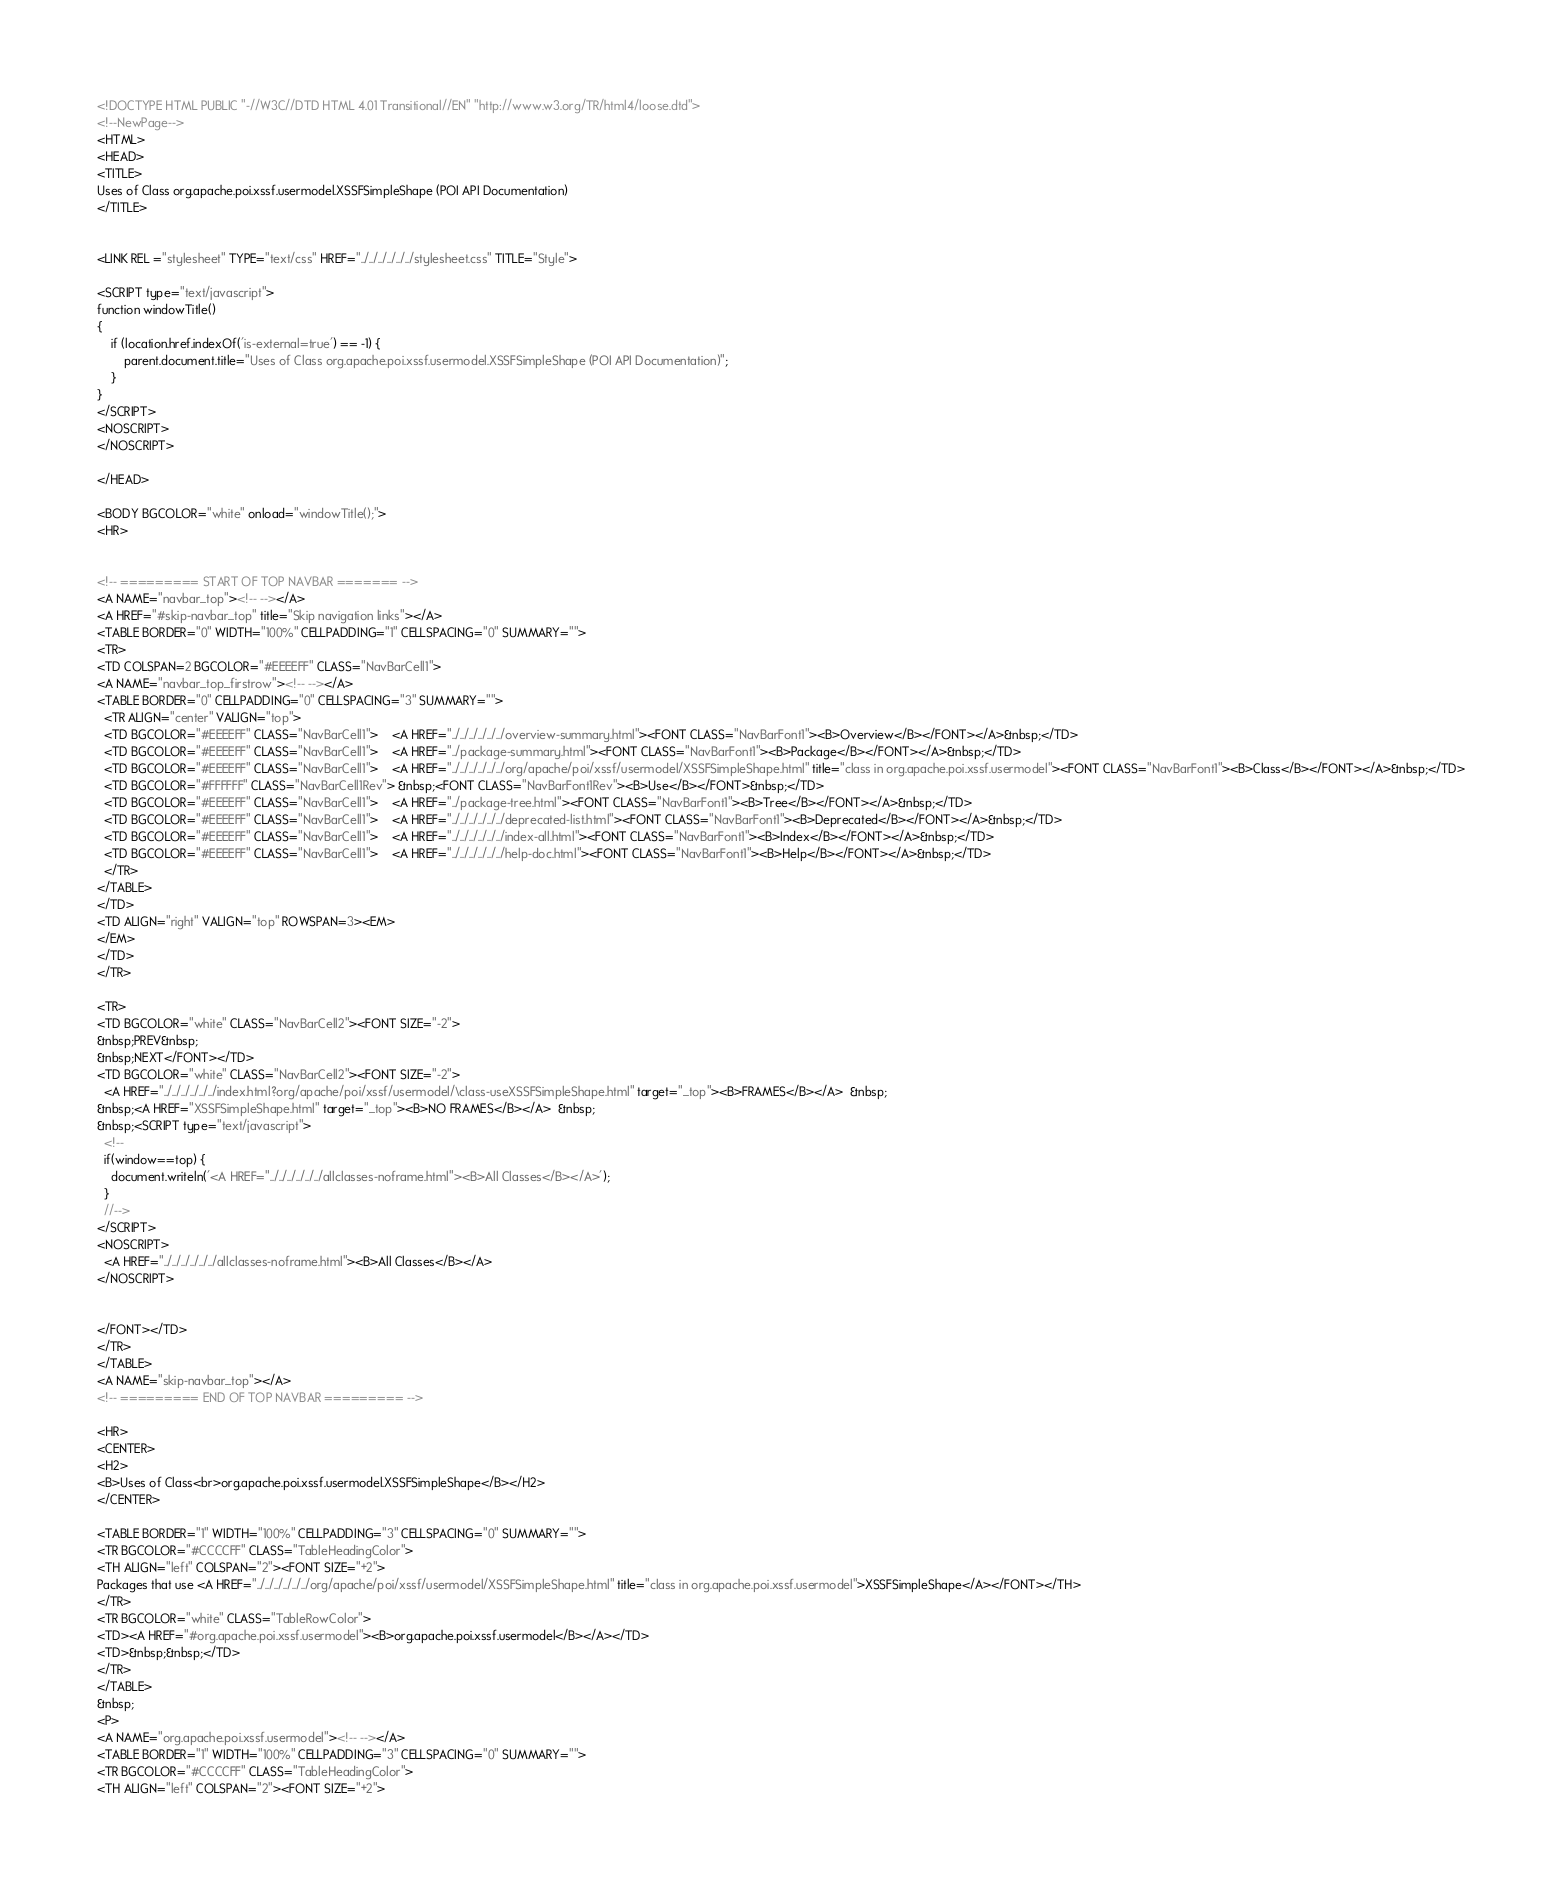Convert code to text. <code><loc_0><loc_0><loc_500><loc_500><_HTML_><!DOCTYPE HTML PUBLIC "-//W3C//DTD HTML 4.01 Transitional//EN" "http://www.w3.org/TR/html4/loose.dtd">
<!--NewPage-->
<HTML>
<HEAD>
<TITLE>
Uses of Class org.apache.poi.xssf.usermodel.XSSFSimpleShape (POI API Documentation)
</TITLE>


<LINK REL ="stylesheet" TYPE="text/css" HREF="../../../../../../stylesheet.css" TITLE="Style">

<SCRIPT type="text/javascript">
function windowTitle()
{
    if (location.href.indexOf('is-external=true') == -1) {
        parent.document.title="Uses of Class org.apache.poi.xssf.usermodel.XSSFSimpleShape (POI API Documentation)";
    }
}
</SCRIPT>
<NOSCRIPT>
</NOSCRIPT>

</HEAD>

<BODY BGCOLOR="white" onload="windowTitle();">
<HR>


<!-- ========= START OF TOP NAVBAR ======= -->
<A NAME="navbar_top"><!-- --></A>
<A HREF="#skip-navbar_top" title="Skip navigation links"></A>
<TABLE BORDER="0" WIDTH="100%" CELLPADDING="1" CELLSPACING="0" SUMMARY="">
<TR>
<TD COLSPAN=2 BGCOLOR="#EEEEFF" CLASS="NavBarCell1">
<A NAME="navbar_top_firstrow"><!-- --></A>
<TABLE BORDER="0" CELLPADDING="0" CELLSPACING="3" SUMMARY="">
  <TR ALIGN="center" VALIGN="top">
  <TD BGCOLOR="#EEEEFF" CLASS="NavBarCell1">    <A HREF="../../../../../../overview-summary.html"><FONT CLASS="NavBarFont1"><B>Overview</B></FONT></A>&nbsp;</TD>
  <TD BGCOLOR="#EEEEFF" CLASS="NavBarCell1">    <A HREF="../package-summary.html"><FONT CLASS="NavBarFont1"><B>Package</B></FONT></A>&nbsp;</TD>
  <TD BGCOLOR="#EEEEFF" CLASS="NavBarCell1">    <A HREF="../../../../../../org/apache/poi/xssf/usermodel/XSSFSimpleShape.html" title="class in org.apache.poi.xssf.usermodel"><FONT CLASS="NavBarFont1"><B>Class</B></FONT></A>&nbsp;</TD>
  <TD BGCOLOR="#FFFFFF" CLASS="NavBarCell1Rev"> &nbsp;<FONT CLASS="NavBarFont1Rev"><B>Use</B></FONT>&nbsp;</TD>
  <TD BGCOLOR="#EEEEFF" CLASS="NavBarCell1">    <A HREF="../package-tree.html"><FONT CLASS="NavBarFont1"><B>Tree</B></FONT></A>&nbsp;</TD>
  <TD BGCOLOR="#EEEEFF" CLASS="NavBarCell1">    <A HREF="../../../../../../deprecated-list.html"><FONT CLASS="NavBarFont1"><B>Deprecated</B></FONT></A>&nbsp;</TD>
  <TD BGCOLOR="#EEEEFF" CLASS="NavBarCell1">    <A HREF="../../../../../../index-all.html"><FONT CLASS="NavBarFont1"><B>Index</B></FONT></A>&nbsp;</TD>
  <TD BGCOLOR="#EEEEFF" CLASS="NavBarCell1">    <A HREF="../../../../../../help-doc.html"><FONT CLASS="NavBarFont1"><B>Help</B></FONT></A>&nbsp;</TD>
  </TR>
</TABLE>
</TD>
<TD ALIGN="right" VALIGN="top" ROWSPAN=3><EM>
</EM>
</TD>
</TR>

<TR>
<TD BGCOLOR="white" CLASS="NavBarCell2"><FONT SIZE="-2">
&nbsp;PREV&nbsp;
&nbsp;NEXT</FONT></TD>
<TD BGCOLOR="white" CLASS="NavBarCell2"><FONT SIZE="-2">
  <A HREF="../../../../../../index.html?org/apache/poi/xssf/usermodel/\class-useXSSFSimpleShape.html" target="_top"><B>FRAMES</B></A>  &nbsp;
&nbsp;<A HREF="XSSFSimpleShape.html" target="_top"><B>NO FRAMES</B></A>  &nbsp;
&nbsp;<SCRIPT type="text/javascript">
  <!--
  if(window==top) {
    document.writeln('<A HREF="../../../../../../allclasses-noframe.html"><B>All Classes</B></A>');
  }
  //-->
</SCRIPT>
<NOSCRIPT>
  <A HREF="../../../../../../allclasses-noframe.html"><B>All Classes</B></A>
</NOSCRIPT>


</FONT></TD>
</TR>
</TABLE>
<A NAME="skip-navbar_top"></A>
<!-- ========= END OF TOP NAVBAR ========= -->

<HR>
<CENTER>
<H2>
<B>Uses of Class<br>org.apache.poi.xssf.usermodel.XSSFSimpleShape</B></H2>
</CENTER>

<TABLE BORDER="1" WIDTH="100%" CELLPADDING="3" CELLSPACING="0" SUMMARY="">
<TR BGCOLOR="#CCCCFF" CLASS="TableHeadingColor">
<TH ALIGN="left" COLSPAN="2"><FONT SIZE="+2">
Packages that use <A HREF="../../../../../../org/apache/poi/xssf/usermodel/XSSFSimpleShape.html" title="class in org.apache.poi.xssf.usermodel">XSSFSimpleShape</A></FONT></TH>
</TR>
<TR BGCOLOR="white" CLASS="TableRowColor">
<TD><A HREF="#org.apache.poi.xssf.usermodel"><B>org.apache.poi.xssf.usermodel</B></A></TD>
<TD>&nbsp;&nbsp;</TD>
</TR>
</TABLE>
&nbsp;
<P>
<A NAME="org.apache.poi.xssf.usermodel"><!-- --></A>
<TABLE BORDER="1" WIDTH="100%" CELLPADDING="3" CELLSPACING="0" SUMMARY="">
<TR BGCOLOR="#CCCCFF" CLASS="TableHeadingColor">
<TH ALIGN="left" COLSPAN="2"><FONT SIZE="+2"></code> 